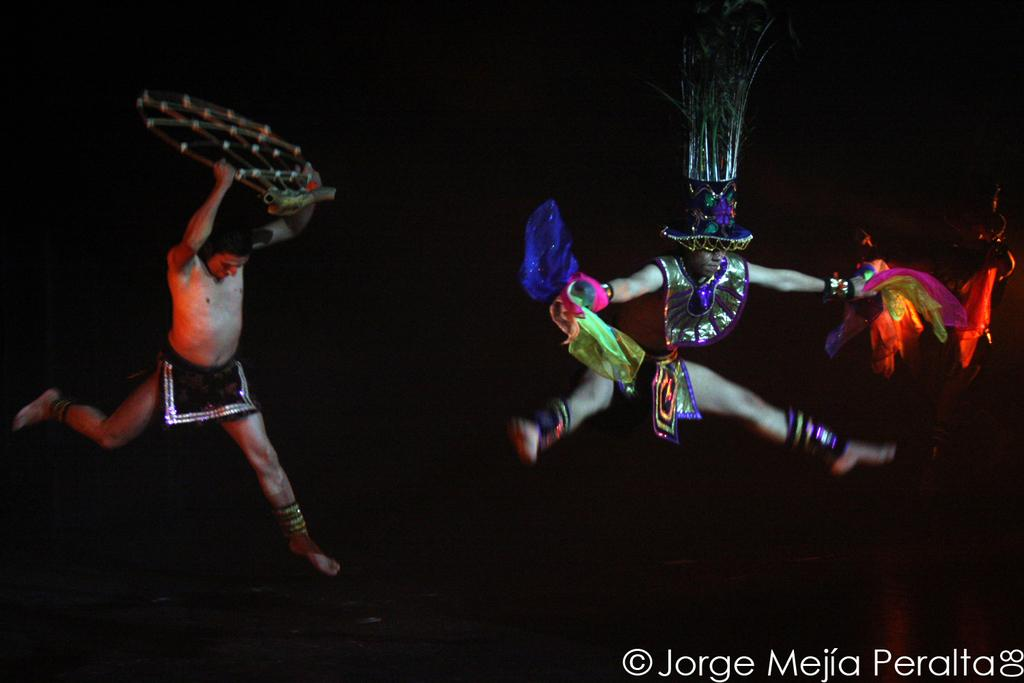What is the main subject of the image? The main subject of the image is men. What are the men doing in the image? The men are performing an art form. What type of food are the men cooking in the image? There is no indication in the image that the men are cooking any food, as they are performing an art form. Can you see any trails or paths in the image? There is no mention of trails or paths in the image; it features men performing an art form. Are there any horses present in the image? There is no mention of horses in the image; it features men performing an art form. 